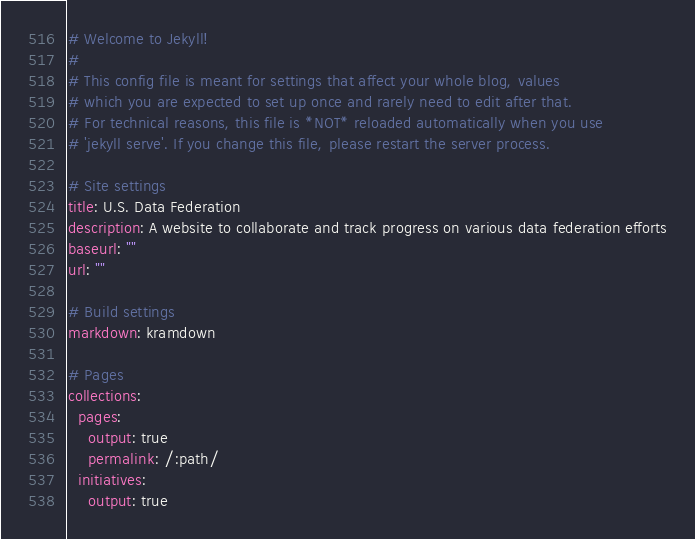<code> <loc_0><loc_0><loc_500><loc_500><_YAML_># Welcome to Jekyll!
#
# This config file is meant for settings that affect your whole blog, values
# which you are expected to set up once and rarely need to edit after that.
# For technical reasons, this file is *NOT* reloaded automatically when you use
# 'jekyll serve'. If you change this file, please restart the server process.

# Site settings
title: U.S. Data Federation
description: A website to collaborate and track progress on various data federation efforts
baseurl: "" 
url: ""

# Build settings
markdown: kramdown

# Pages
collections:
  pages:
    output: true
    permalink: /:path/
  initiatives:
    output: true</code> 